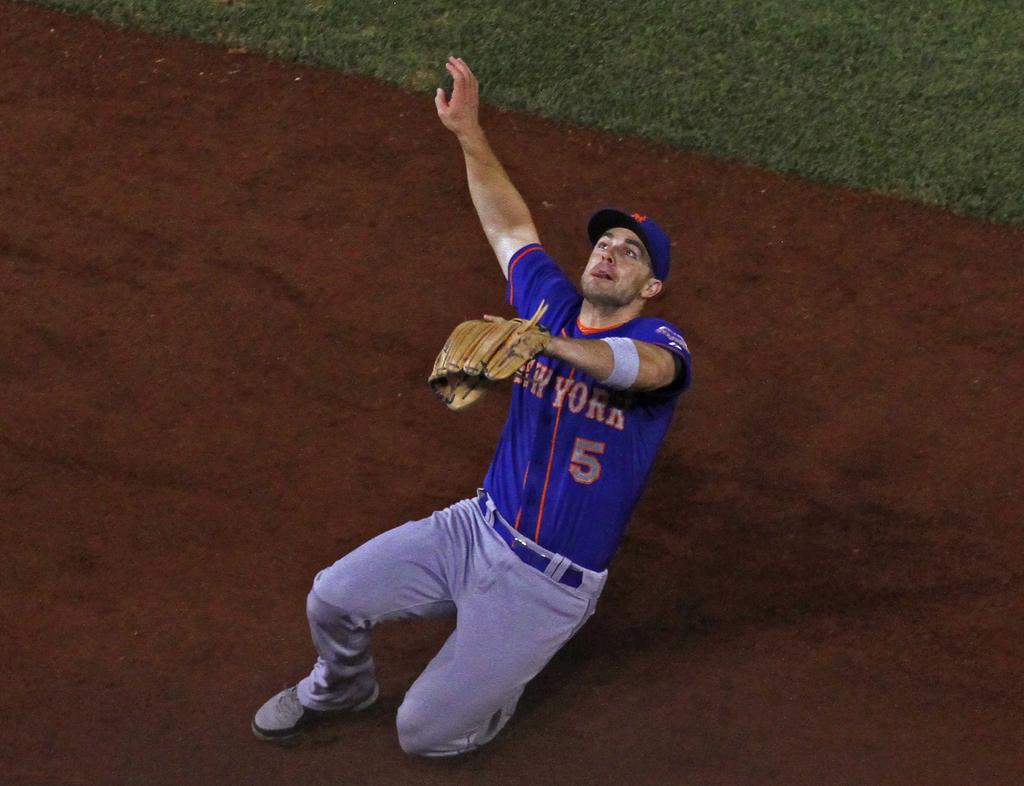<image>
Create a compact narrative representing the image presented. A man on a sports field with the number five on his shirt. 